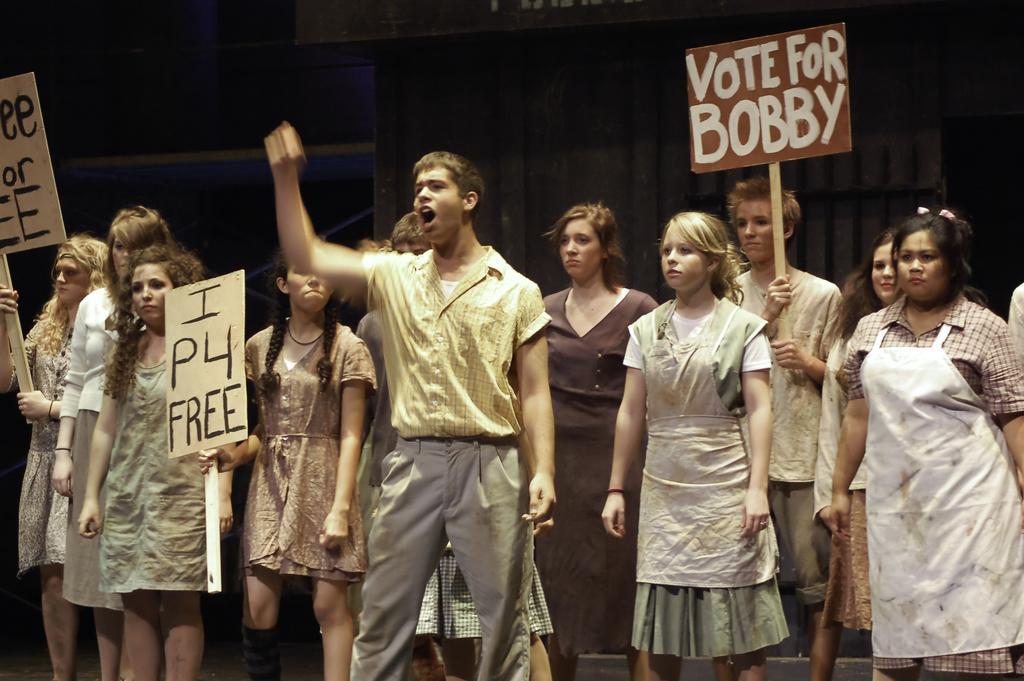In one or two sentences, can you explain what this image depicts? In the image there are a group of people and some of them are holding few boards in their hands, it looks like they are protesting against something. 